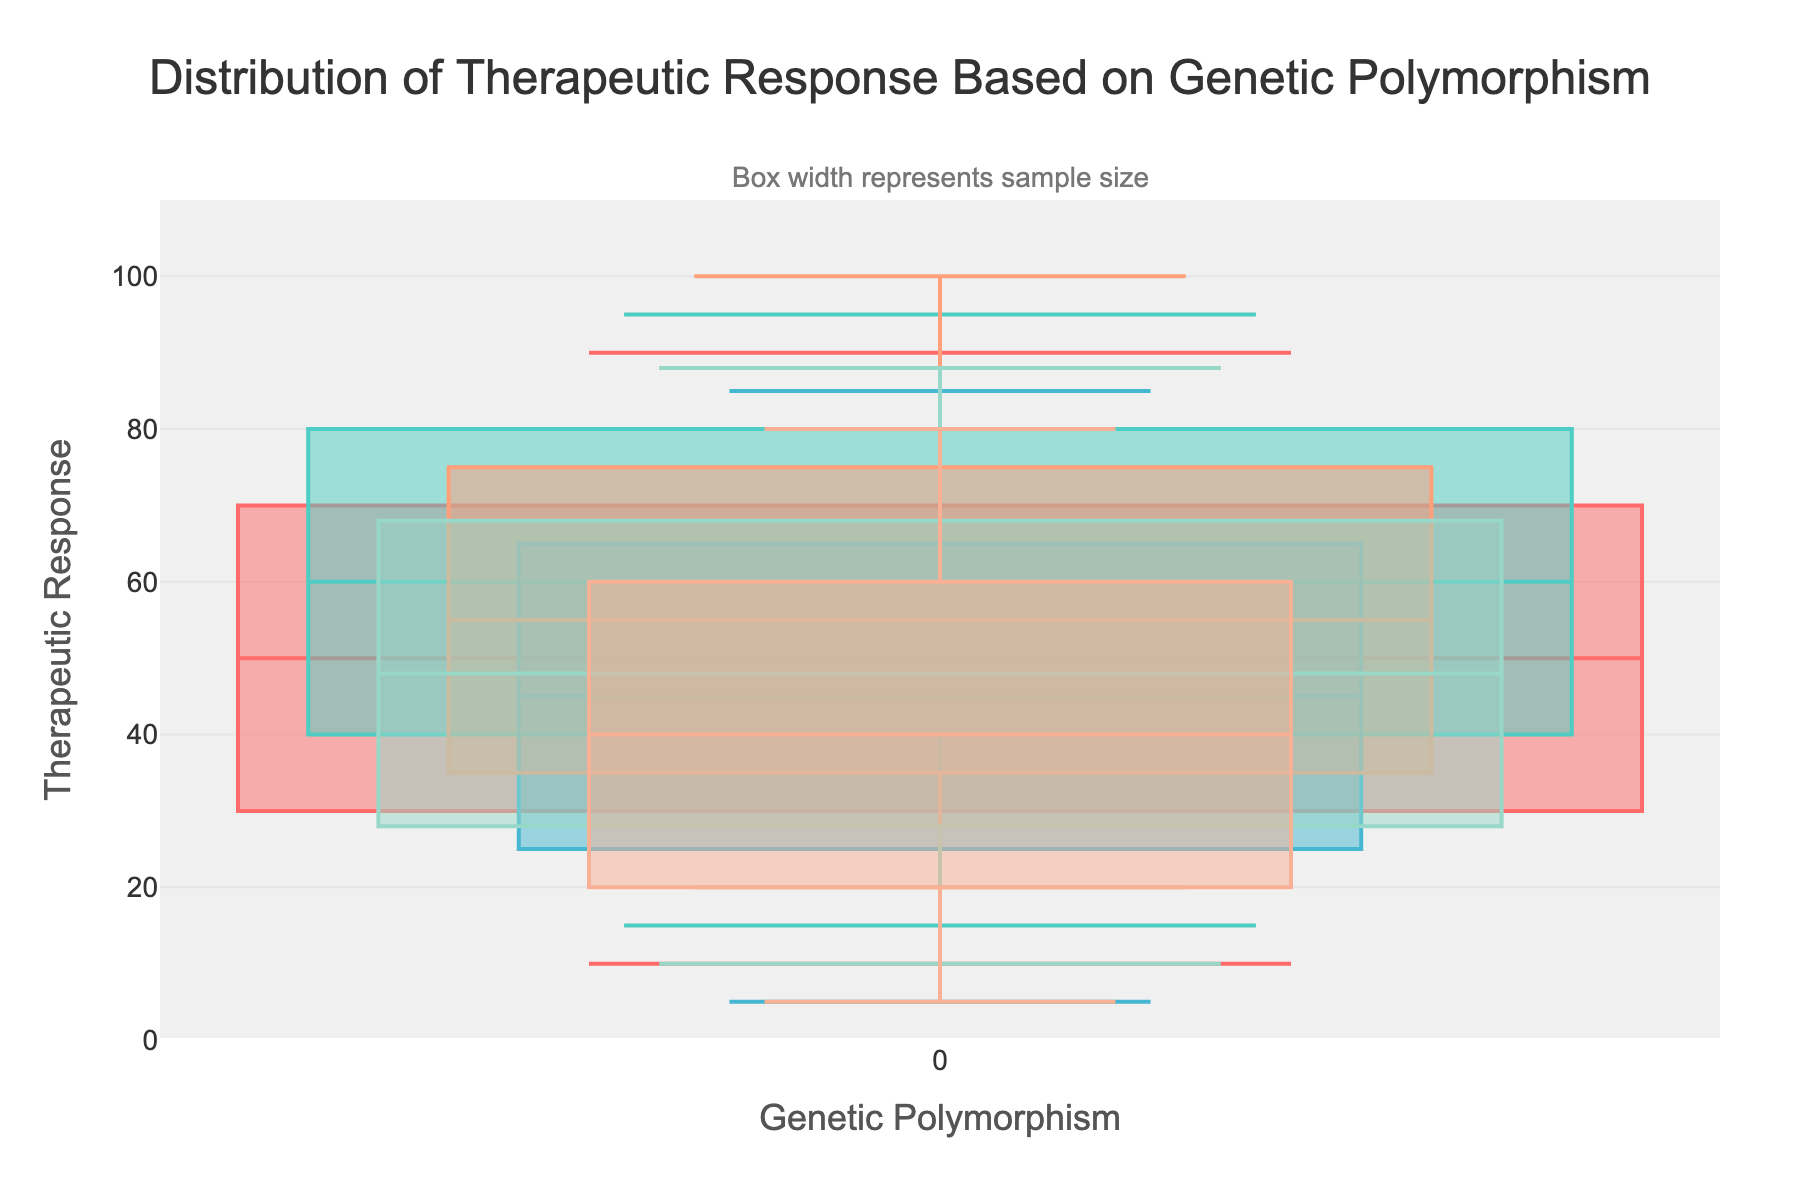Which genetic polymorphism has the highest median therapeutic response? The genetic polymorphism 'CYP2D6*1/*2' has the highest median therapeutic response, represented by the central line in each box. It has a median response of 60.
Answer: CYP2D6*1/*2 Which genetic polymorphism sample group is the largest? To determine the largest sample group, look at the width of each box plot. The group with the widest box is 'CYP2D6*1/*1', indicating it has the largest sample size of 50.
Answer: CYP2D6*1/*1 What is the range of therapeutic response for CYP2D6*2/*2? The range is calculated by subtracting the minimum value from the maximum value. For 'CYP2D6*2/*2,' the range is 85 - 5 = 80.
Answer: 80 How does the interquartile range (IQR) of CYP2D6*1/*1 compare to CYP2D6*4/*4? The IQR is calculated as the 75th percentile minus the 25th percentile. For 'CYP2D6*1/*1,' the IQR is 70 - 30 = 40. For 'CYP2D6*4/*4,' the IQR is 60 - 20 = 40. The IQRs are equal.
Answer: The IQRs are equal at 40 Which genetic polymorphism has the lowest minimum therapeutic response? Looking at the lower fence of the boxes, 'CYP2D6*2/*2' and 'CYP2D6*4/*4' share the lowest minimum therapeutic response, both at a value of 5.
Answer: CYP2D6*2/*2 and CYP2D6*4/*4 How does the maximum therapeutic response of CYP2D6*1/*3 compare to the other groups? The maximum therapeutic response for 'CYP2D6*1/*3' is 100, which is higher than all other groups. The next closest is 'CYP2D6*1/*2' with a maximum of 95.
Answer: Higher than all other groups What is the median therapeutic response for CYP2D6*3/*4, and how does it compare to CYP2D6*1/*2? The median response for 'CYP2D6*3/*4' is 48, whereas for 'CYP2D6*1/*2,' it is 60. Hence, the median response for 'CYP2D6*1/*2' is higher by 12 units.
Answer: CYP2D6*1/*2 is higher by 12 units What does the annotation in the plot say? The annotation states, "Box width represents sample size," which helps to interpret the width of the boxes in context.
Answer: Box width represents sample size 